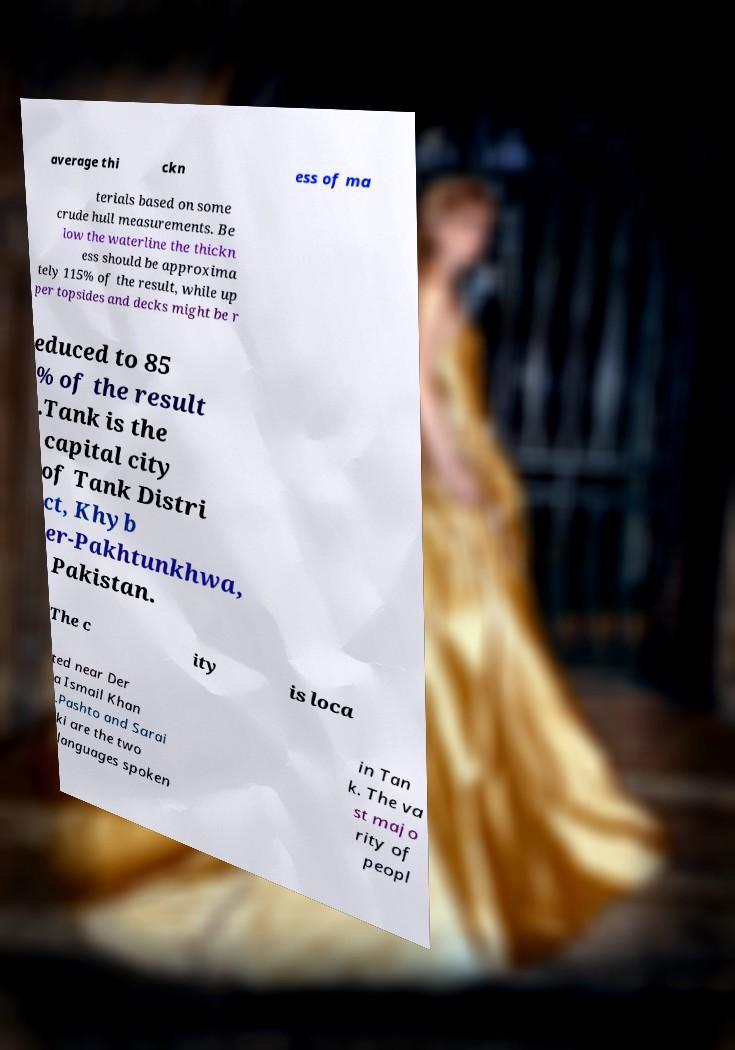There's text embedded in this image that I need extracted. Can you transcribe it verbatim? average thi ckn ess of ma terials based on some crude hull measurements. Be low the waterline the thickn ess should be approxima tely 115% of the result, while up per topsides and decks might be r educed to 85 % of the result .Tank is the capital city of Tank Distri ct, Khyb er-Pakhtunkhwa, Pakistan. The c ity is loca ted near Der a Ismail Khan .Pashto and Sarai ki are the two languages spoken in Tan k. The va st majo rity of peopl 